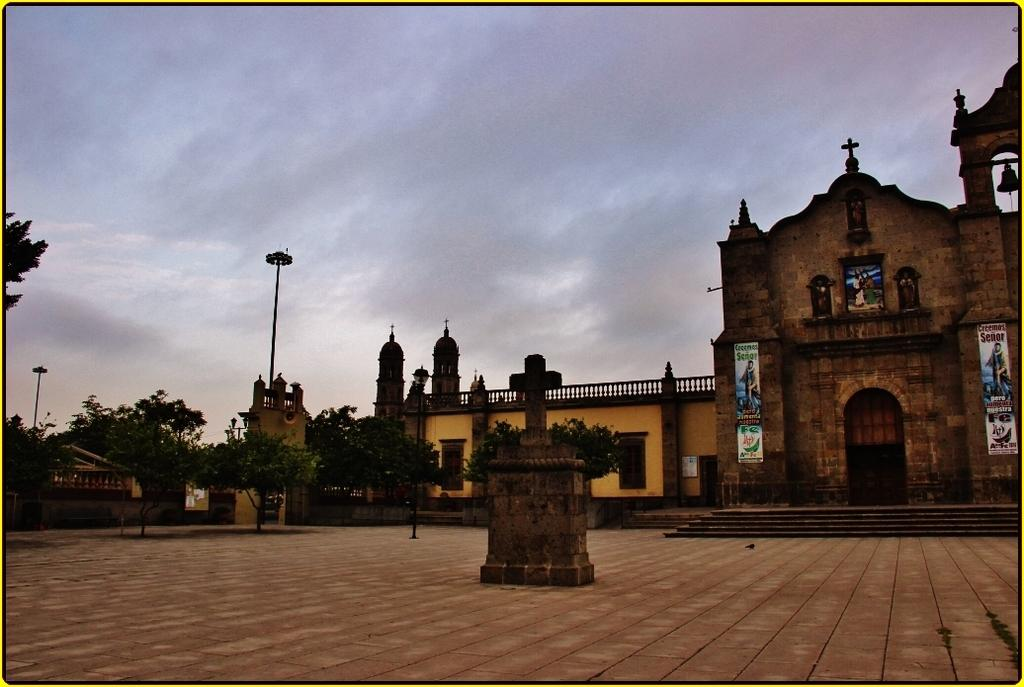What type of structures can be seen in the image? There are buildings in the image. What architectural elements are present on the ground in the image? There are pillars on the ground in the image. What is on the wall in the image? There is a wall with posters in the image, and a bell is also on the wall. What type of vegetation is visible in the image? There are trees in the image. What type of street furniture can be seen in the image? There is a light pole in the image. What part of the natural environment is visible in the image? The sky is visible in the image. How many bikes are parked near the trees in the image? There are no bikes present in the image. What type of ink is used for the posters on the wall in the image? There is no information about the ink used for the posters in the image. 